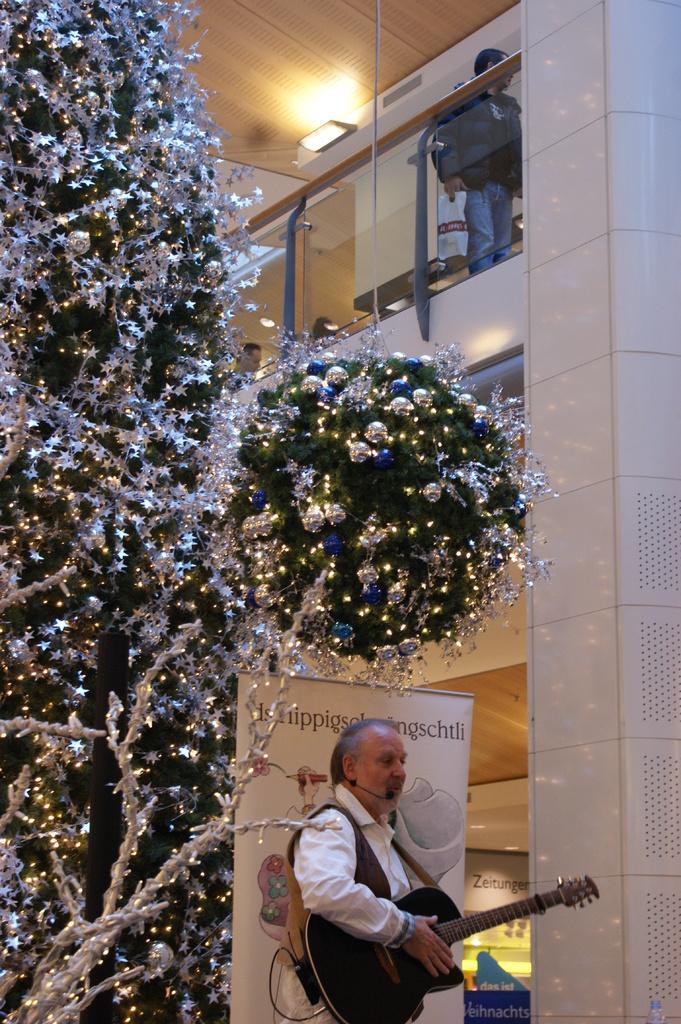How would you summarize this image in a sentence or two? As we can see in the image there is a wall, Christmas tree, a person holding guitar, banner and on the top there is another person holding cover. 